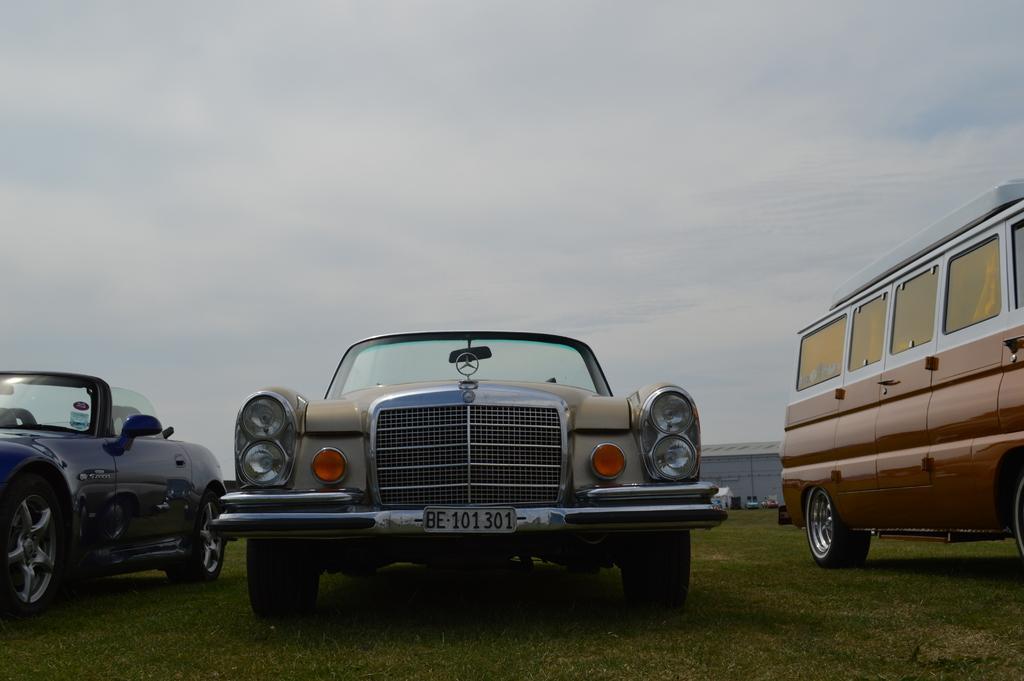Could you give a brief overview of what you see in this image? In this picture there is a car. On the right we can see mini bus. On the left we can see sports car. On the bottom we can see grass. In the background there is a shed. On the top we can see sky and clouds. 